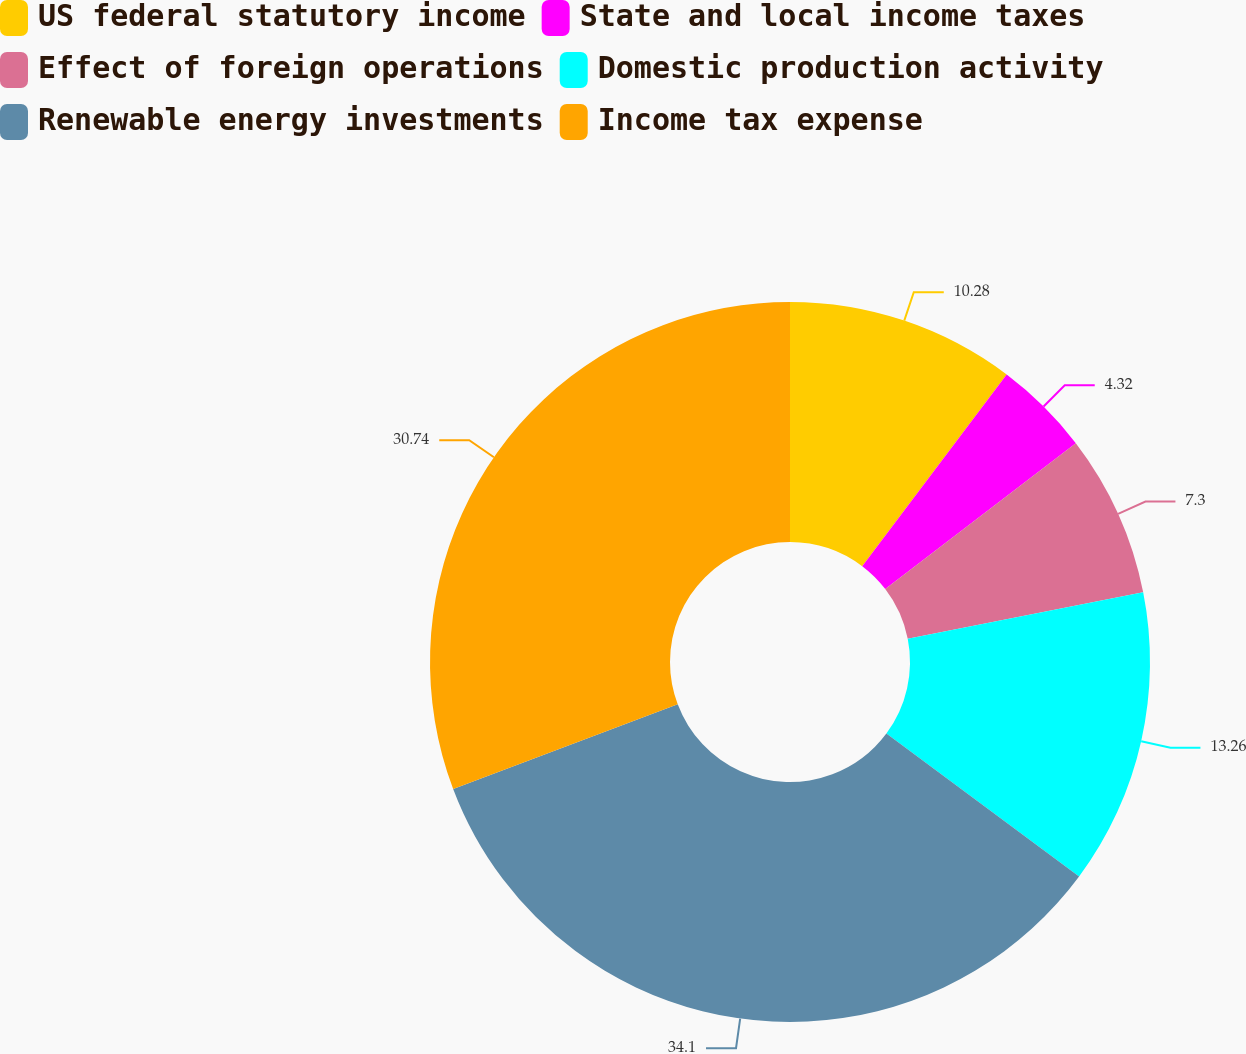<chart> <loc_0><loc_0><loc_500><loc_500><pie_chart><fcel>US federal statutory income<fcel>State and local income taxes<fcel>Effect of foreign operations<fcel>Domestic production activity<fcel>Renewable energy investments<fcel>Income tax expense<nl><fcel>10.28%<fcel>4.32%<fcel>7.3%<fcel>13.26%<fcel>34.1%<fcel>30.74%<nl></chart> 